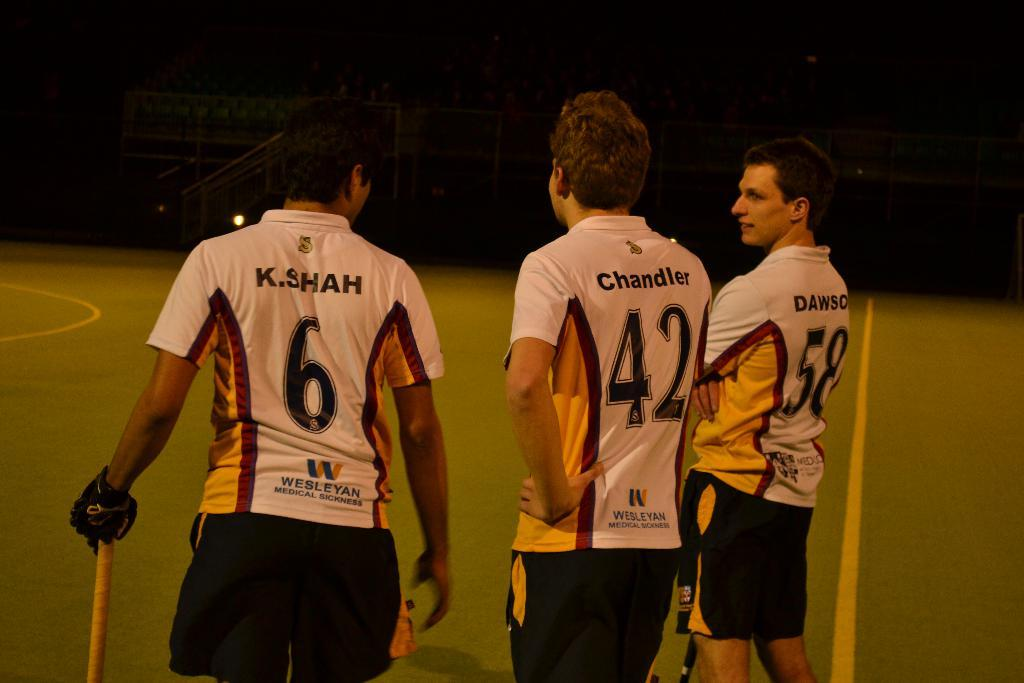<image>
Create a compact narrative representing the image presented. players named shah, chandler, and dawson wearing jerseys for wesleyan medical sickness 